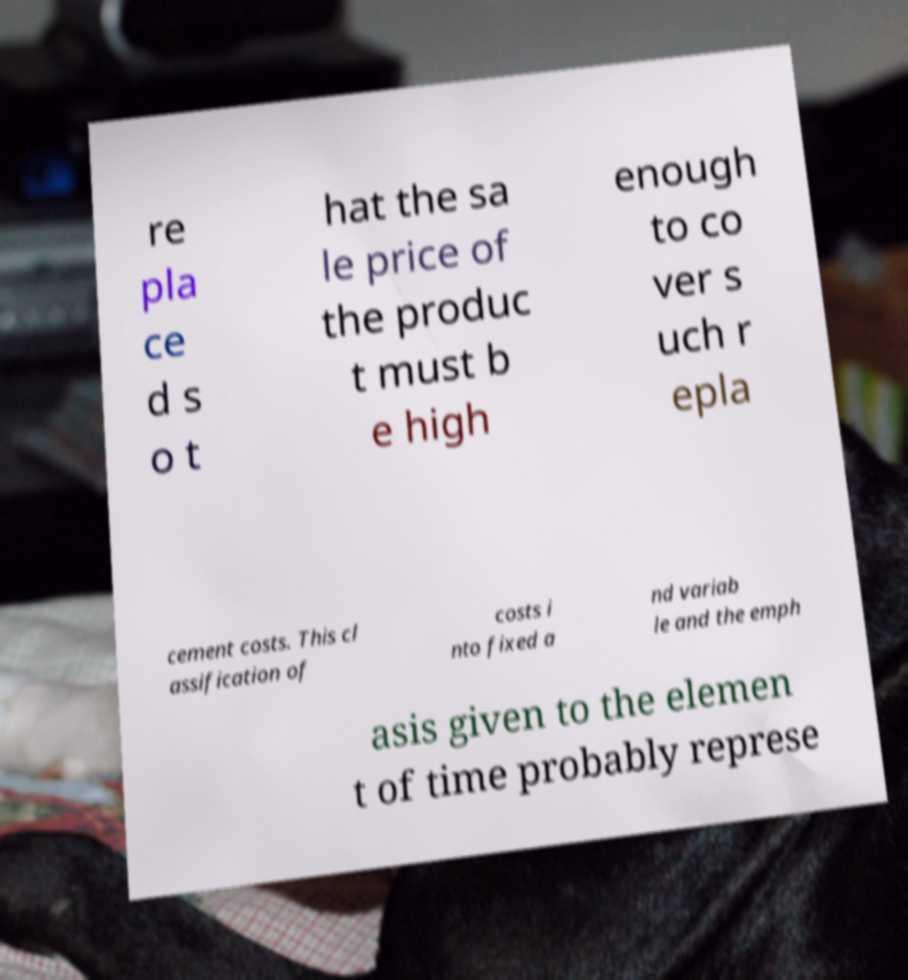Please read and relay the text visible in this image. What does it say? re pla ce d s o t hat the sa le price of the produc t must b e high enough to co ver s uch r epla cement costs. This cl assification of costs i nto fixed a nd variab le and the emph asis given to the elemen t of time probably represe 